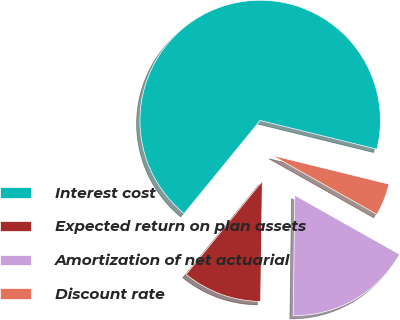<chart> <loc_0><loc_0><loc_500><loc_500><pie_chart><fcel>Interest cost<fcel>Expected return on plan assets<fcel>Amortization of net actuarial<fcel>Discount rate<nl><fcel>67.93%<fcel>10.69%<fcel>17.05%<fcel>4.33%<nl></chart> 